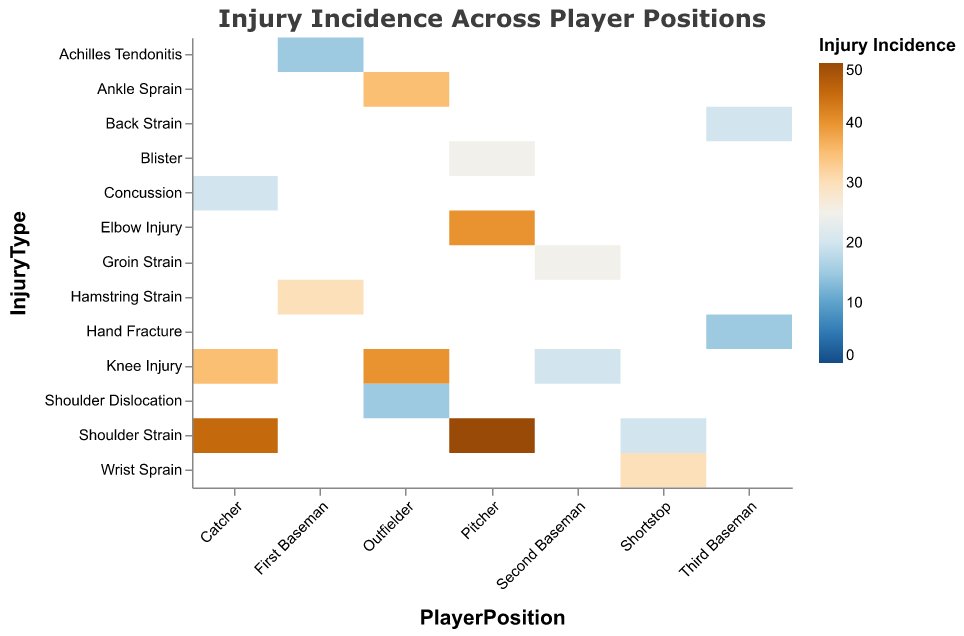What is the most common injury for Catchers? By looking at the color scale for the Catcher row and finding the darkest color, we see the highest incidence is for "Shoulder Strain" which is at 45.
Answer: Shoulder Strain Which position has the highest average recovery time for an injury? By comparing the tooltip data, Pitchers with "Elbow Injury" have the longest recovery time. The average recovery time is 60 days.
Answer: Pitcher with Elbow Injury Among the listed injuries, which one occurs more frequently for Outfielders? Checking the colors in the Outfielders row, we see that Knee Injury has the darkest color, indicating the highest frequency at 40.
Answer: Knee Injury What is the average recovery time for Knee Injuries across all positions? We need to find the mean of the recovery times for Knee Injuries: Catcher (50), Second Baseman (35), Outfielder (35). (50 + 35 + 35)/3 = 40.
Answer: 40 days Which position has the least frequent injury, and what is it? By looking for the lightest color indicating the lowest incidence, First Baseman's Achilles Tendonitis at 15 is the least frequent.
Answer: First Baseman with Achilles Tendonitis How do Shoulder Strain injuries differ in incidence for Catchers vs. Pitchers? The color for Shoulder Strain in the Catchers row is lighter than in the Pitchers row. For Catchers, it's 45 and for Pitchers, it's 50.
Answer: Pitchers have a higher incidence (50) than Catchers (45) Compare the average recovery time for Shoulder Strains between Catchers and Shortstops. The average recovery time for Catchers with Shoulder Strain is 30 days, while for Shortstops it is also 30 days.
Answer: Equal, 30 days What injury type has the largest difference in recovery time across all positions? By comparing the recovery times in each heatmap cell, Elbow Injuries for Pitchers (60) vs. the second largest, Shoulder Strain for Pitchers (45), shows the largest difference of 15 days.
Answer: Elbow Injury (Pitchers) 60 minus Shoulder Strain (Pitchers) 45 = 15 days How does the incidence of Knee Injuries for Catchers compare to that for Outfielders? For Catchers, Knee Injuries have an incidence of 35 while for Outfielders it is 40. The incidence is higher for Outfielders.
Answer: Outfielders have a higher incidence (40) than Catchers (35) 